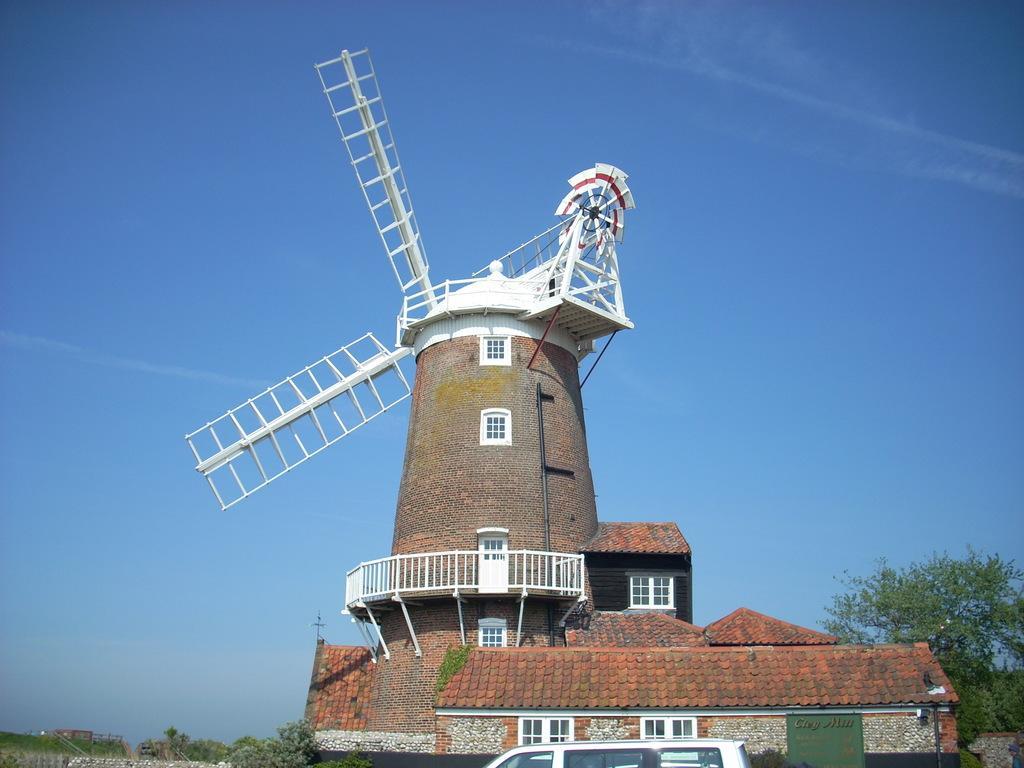In one or two sentences, can you explain what this image depicts? In the picture I can see a windmill and there is a vehicle in front of it and there are trees in the background. 